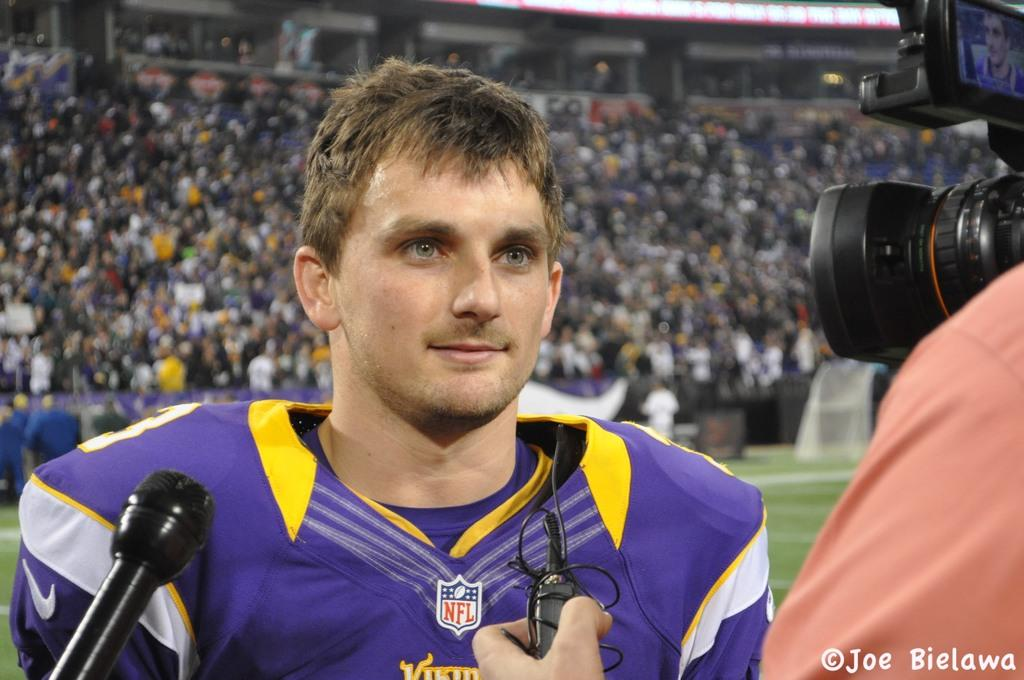<image>
Relay a brief, clear account of the picture shown. A Vikings player with an NFL logo on his shirt talks to the reporter. 